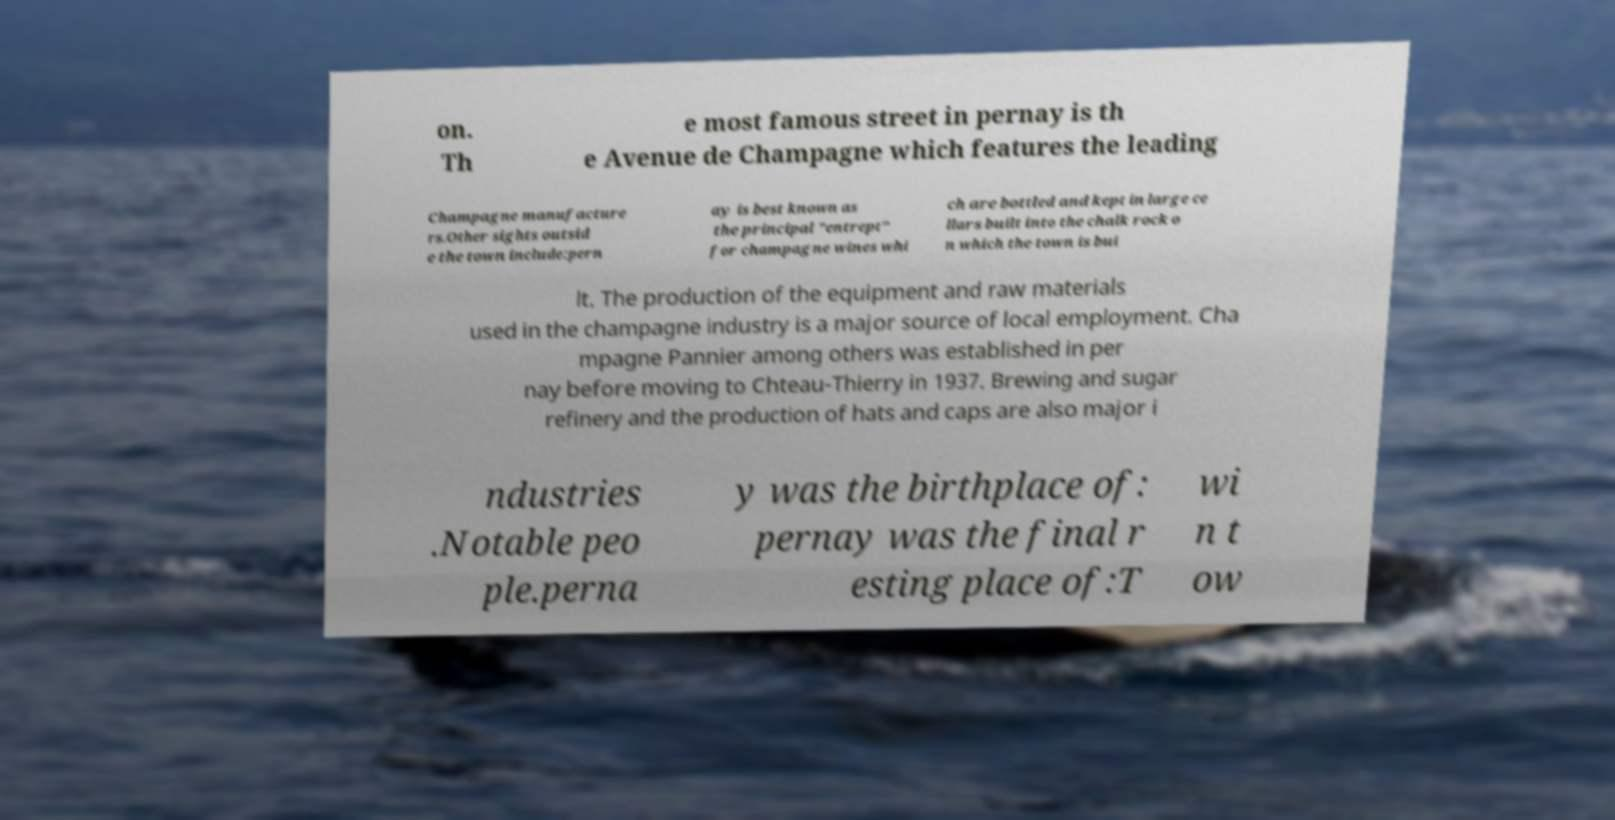I need the written content from this picture converted into text. Can you do that? on. Th e most famous street in pernay is th e Avenue de Champagne which features the leading Champagne manufacture rs.Other sights outsid e the town include:pern ay is best known as the principal "entrept" for champagne wines whi ch are bottled and kept in large ce llars built into the chalk rock o n which the town is bui lt. The production of the equipment and raw materials used in the champagne industry is a major source of local employment. Cha mpagne Pannier among others was established in per nay before moving to Chteau-Thierry in 1937. Brewing and sugar refinery and the production of hats and caps are also major i ndustries .Notable peo ple.perna y was the birthplace of: pernay was the final r esting place of:T wi n t ow 